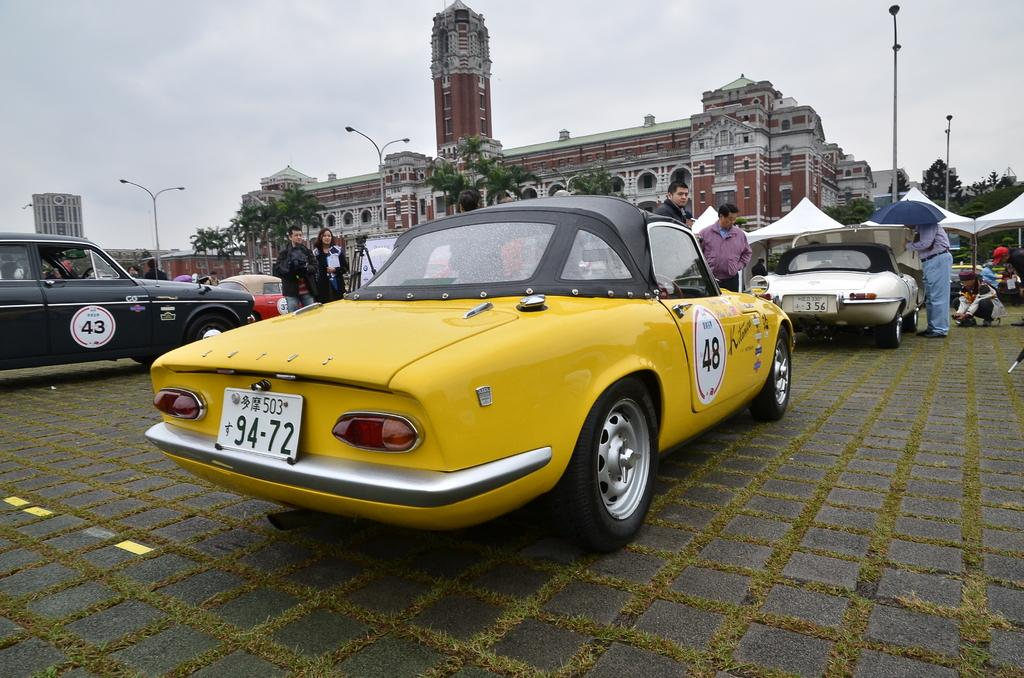What type of vehicles can be seen in the image? There are cars in the image. What else is present in the image besides cars? There is a group of people and tents in the background of the image. Can you describe the background of the image? The background of the image includes trees, poles, and buildings. What are the people in the image doing? There are people seated in the image. What type of farm animals can be seen in the image? There are no farm animals present in the image. What type of war equipment can be seen in the image? There is no war equipment present in the image. 